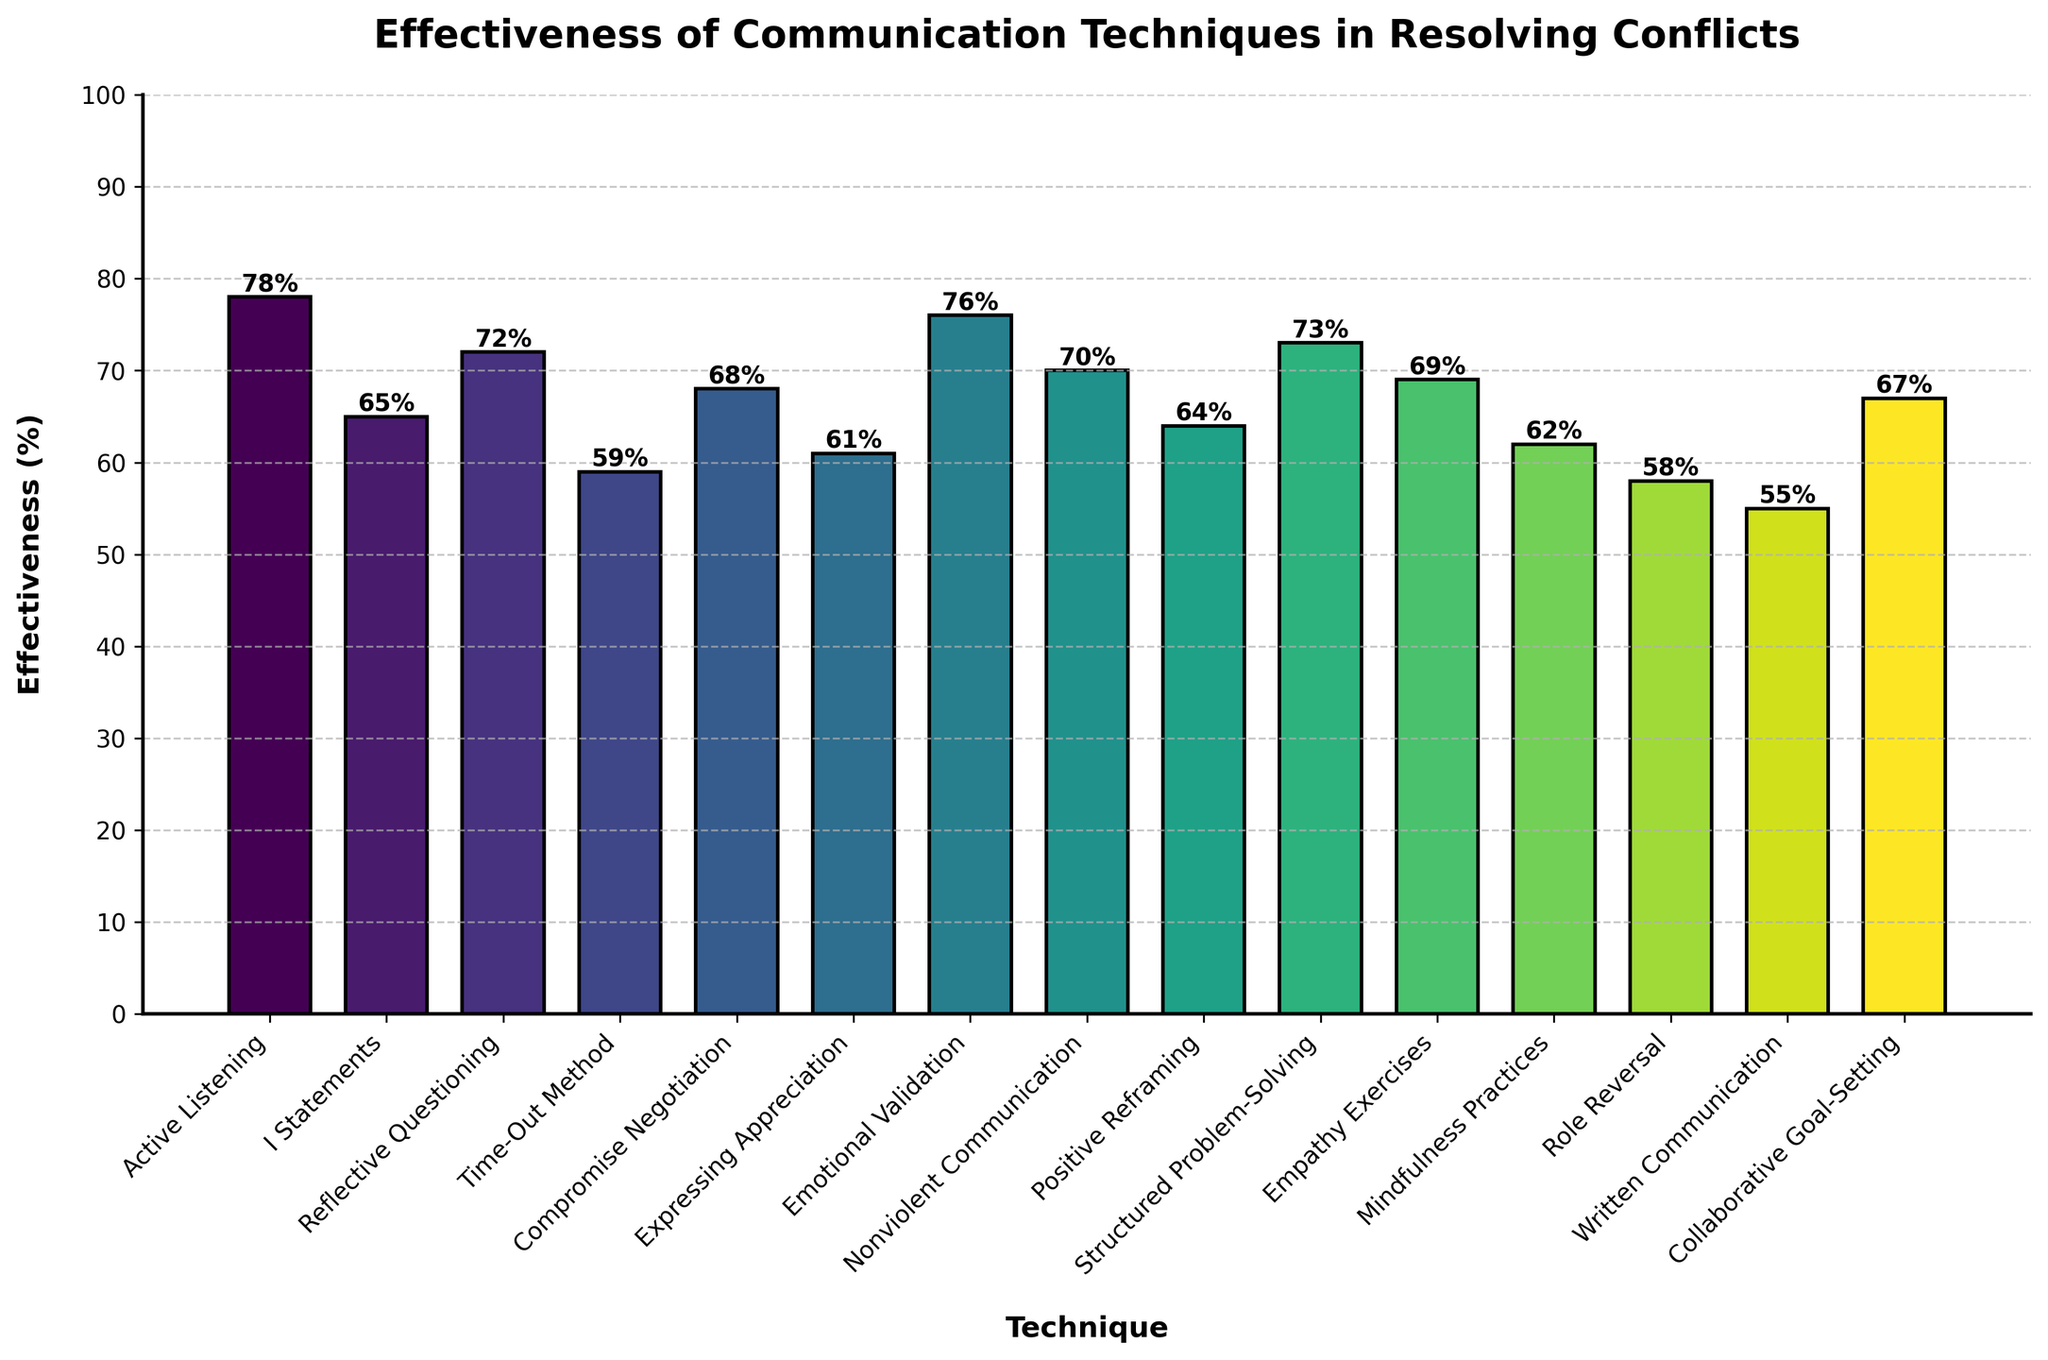What is the most effective communication technique in resolving conflicts? By examining the figure, the height of the bar representing "Active Listening" is the tallest, indicating it has the highest effectiveness percentage.
Answer: Active Listening Which technique has the lowest effectiveness percentage? The bar representing "Written Communication" is the shortest in the figure, indicating it has the lowest effectiveness percentage.
Answer: Written Communication What is the difference in effectiveness between "Active Listening" and "Written Communication"? The effectiveness of "Active Listening" is 78%, and "Written Communication" is 55%. Subtracting these gives 78% - 55% = 23%.
Answer: 23% Among "Compromise Negotiation", "Expressing Appreciation", and "Mindfulness Practices", which technique is the most effective? Comparing the heights of the bars, "Compromise Negotiation" has an effectiveness of 68%, "Expressing Appreciation" is 61%, and "Mindfulness Practices" is 62%. The tallest bar is for "Compromise Negotiation".
Answer: Compromise Negotiation Is "Role Reversal" more effective than "Written Communication"? By noticing the height of the bars, "Role Reversal" has an effectiveness of 58% and "Written Communication" is 55%. Since 58% > 55%, "Role Reversal" is more effective.
Answer: Yes What is the average effectiveness of "Emotional Validation", "Nonviolent Communication", and "Structured Problem-Solving"? The effectiveness percentages are "Emotional Validation" (76%), "Nonviolent Communication" (70%), "Structured Problem-Solving" (73%). Summing these gives 76% + 70% + 73% = 219%, then dividing by 3 yields 219% / 3 = 73%.
Answer: 73% Which techniques have an effectiveness above 70%? By examining the heights of the bars, the techniques above 70% are "Active Listening" (78%), "Reflective Questioning" (72%), "Structured Problem-Solving" (73%), and "Emotional Validation" (76%).
Answer: Active Listening, Reflective Questioning, Structured Problem-Solving, Emotional Validation Is the effectiveness of "Time-Out Method" closer to that of "Expressing Appreciation" or "Mindfulness Practices"? "Time-Out Method" is 59%, "Expressing Appreciation" is 61%, and "Mindfulness Practices" is 62%. The difference between "Time-Out Method" and "Expressing Appreciation" is 2%, and the difference between "Time-Out Method" and "Mindfulness Practices" is 3%. So, it is closer to "Expressing Appreciation".
Answer: Expressing Appreciation 